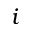Convert formula to latex. <formula><loc_0><loc_0><loc_500><loc_500>i</formula> 